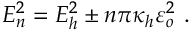Convert formula to latex. <formula><loc_0><loc_0><loc_500><loc_500>E _ { n } ^ { 2 } = E _ { h } ^ { 2 } \pm n \pi \kappa _ { h } \varepsilon _ { o } ^ { 2 } \ .</formula> 